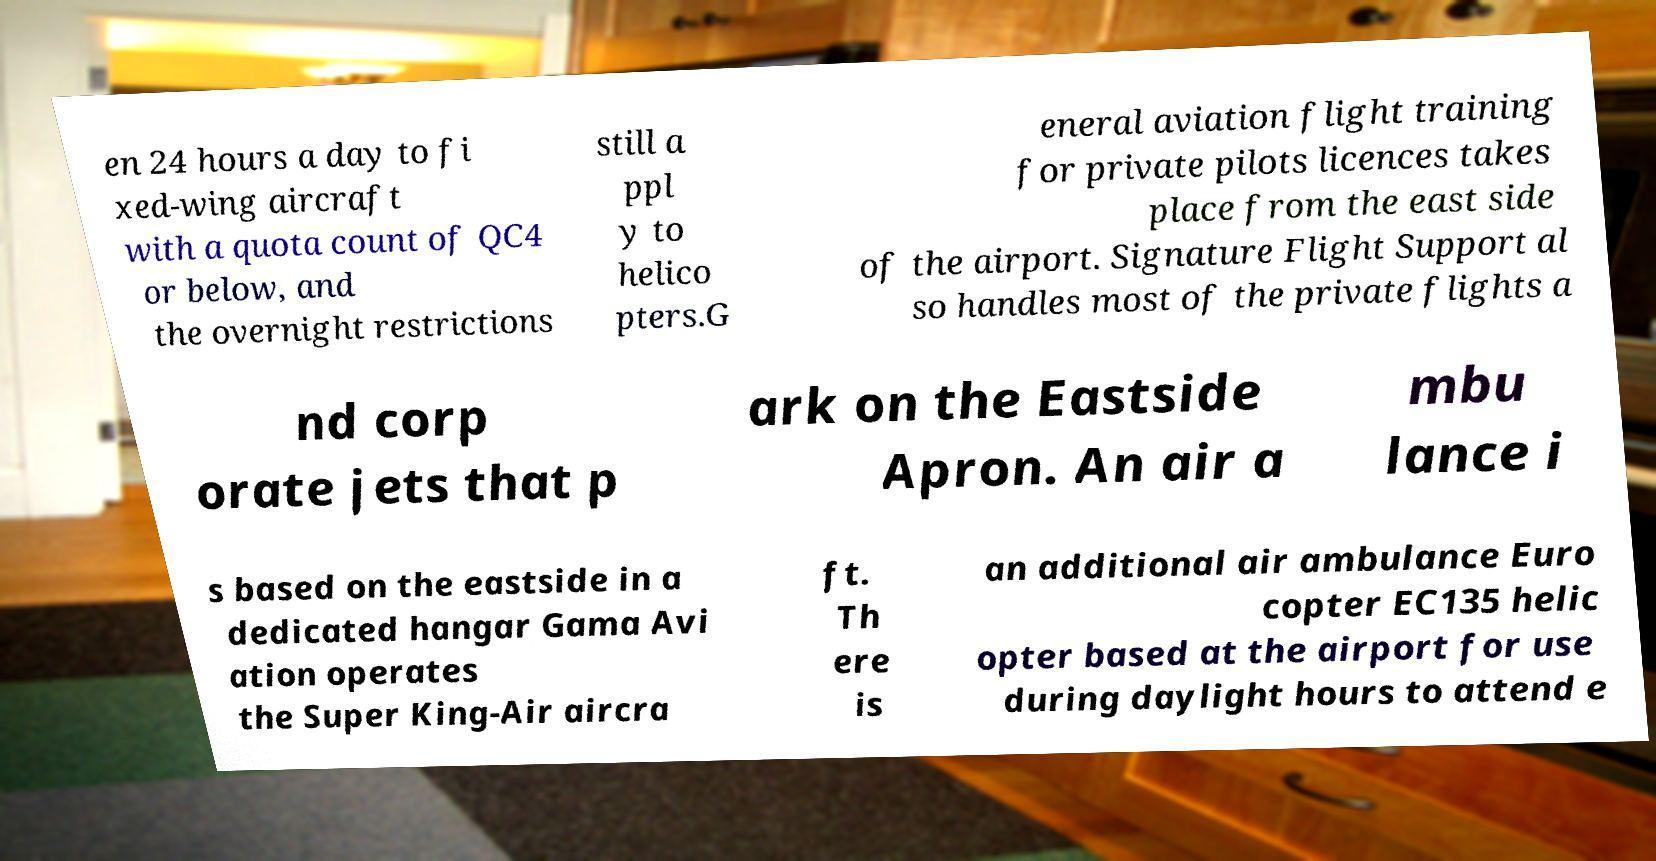Could you assist in decoding the text presented in this image and type it out clearly? en 24 hours a day to fi xed-wing aircraft with a quota count of QC4 or below, and the overnight restrictions still a ppl y to helico pters.G eneral aviation flight training for private pilots licences takes place from the east side of the airport. Signature Flight Support al so handles most of the private flights a nd corp orate jets that p ark on the Eastside Apron. An air a mbu lance i s based on the eastside in a dedicated hangar Gama Avi ation operates the Super King-Air aircra ft. Th ere is an additional air ambulance Euro copter EC135 helic opter based at the airport for use during daylight hours to attend e 